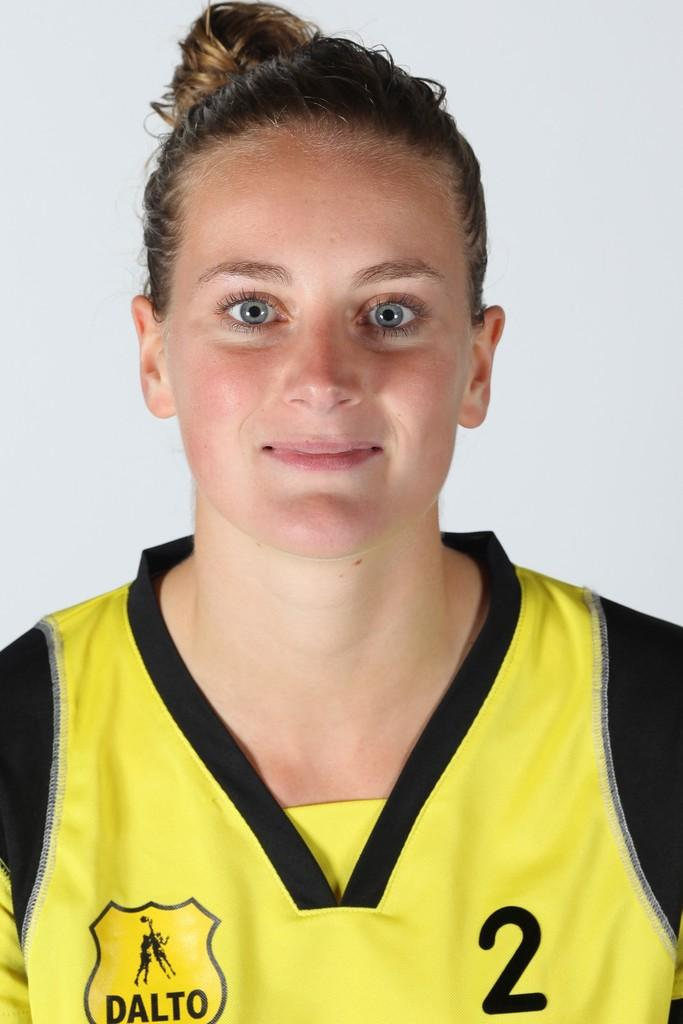Provide a one-sentence caption for the provided image. A girl wearing a yellow and black shirt with Dalto and the number two on the shirt. 